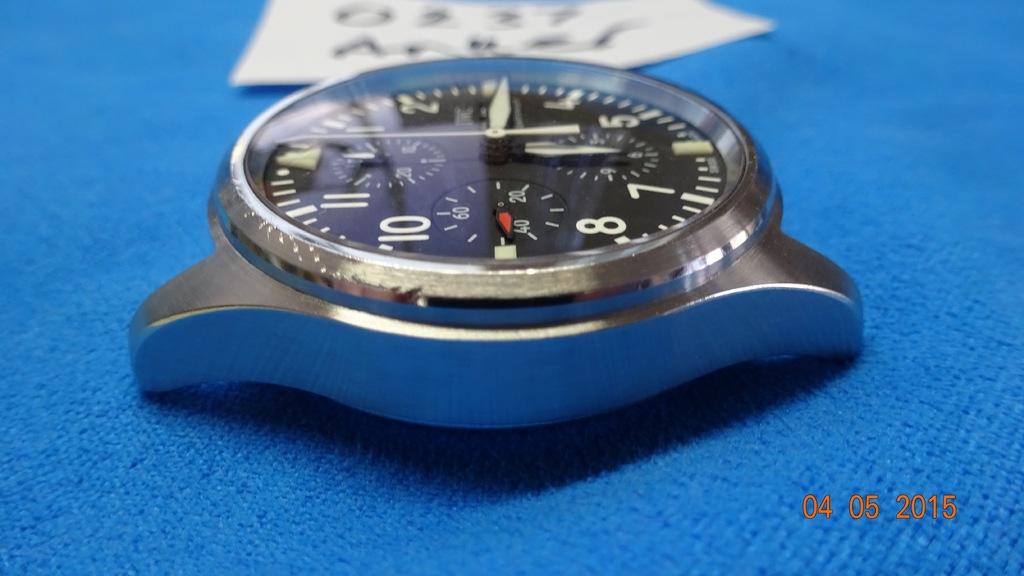What time does the watch show?
Your response must be concise. 3:00. 